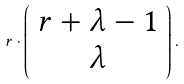Convert formula to latex. <formula><loc_0><loc_0><loc_500><loc_500>r \cdot \left ( \begin{array} { c } r + \lambda - 1 \\ \lambda \end{array} \right ) .</formula> 